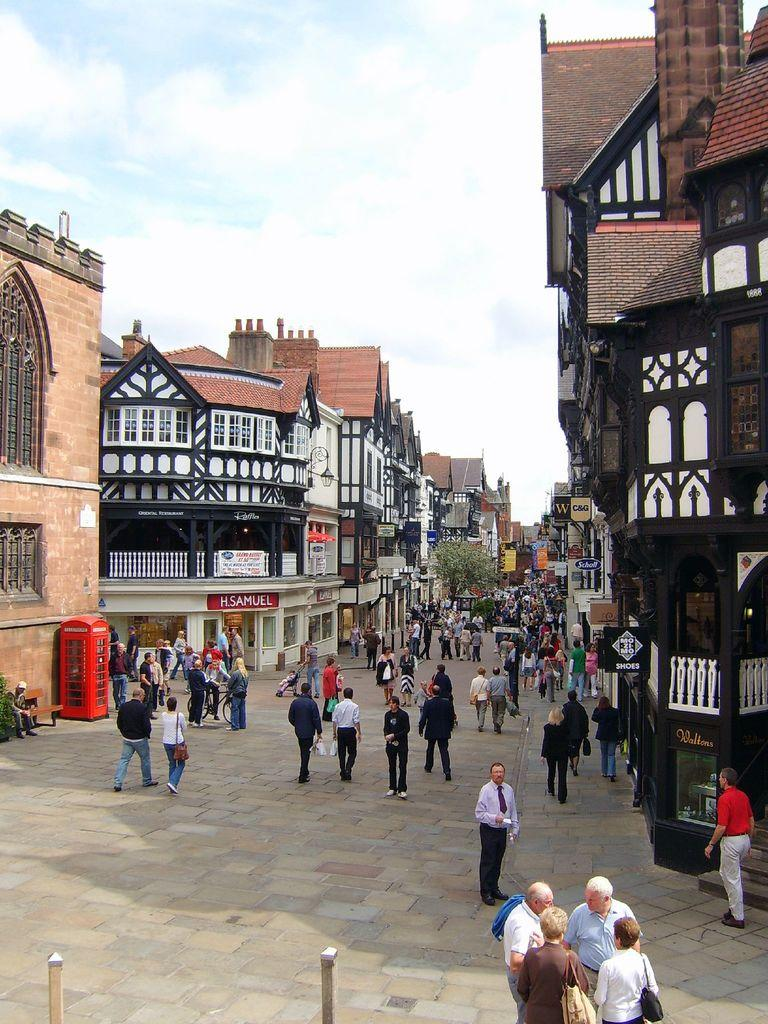What is happening in the image? There are people standing in the image. What can be seen in the background behind the people? There are buildings on either side of the people. Can you describe any specific objects in the image? There is a red color telephone booth in the left corner of the image. What type of sticks are the people using to wave at each other in the image? There are no sticks or waving actions present in the image. 